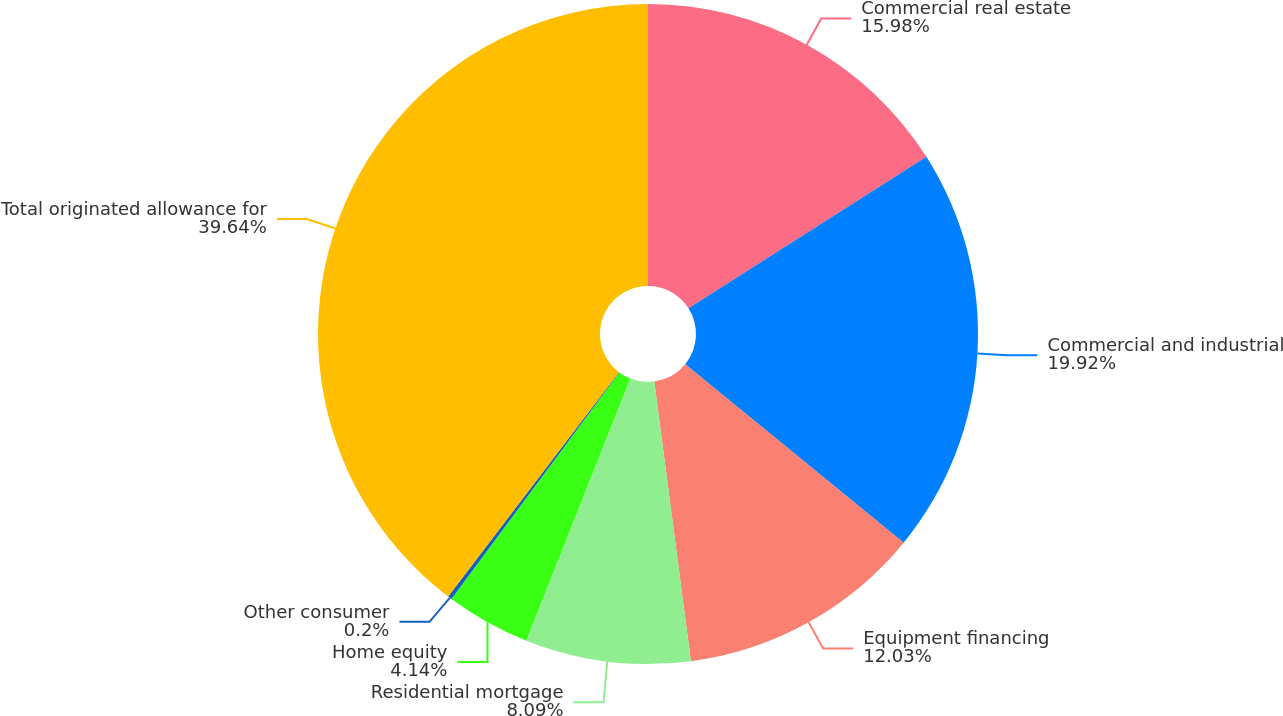Convert chart to OTSL. <chart><loc_0><loc_0><loc_500><loc_500><pie_chart><fcel>Commercial real estate<fcel>Commercial and industrial<fcel>Equipment financing<fcel>Residential mortgage<fcel>Home equity<fcel>Other consumer<fcel>Total originated allowance for<nl><fcel>15.98%<fcel>19.92%<fcel>12.03%<fcel>8.09%<fcel>4.14%<fcel>0.2%<fcel>39.65%<nl></chart> 